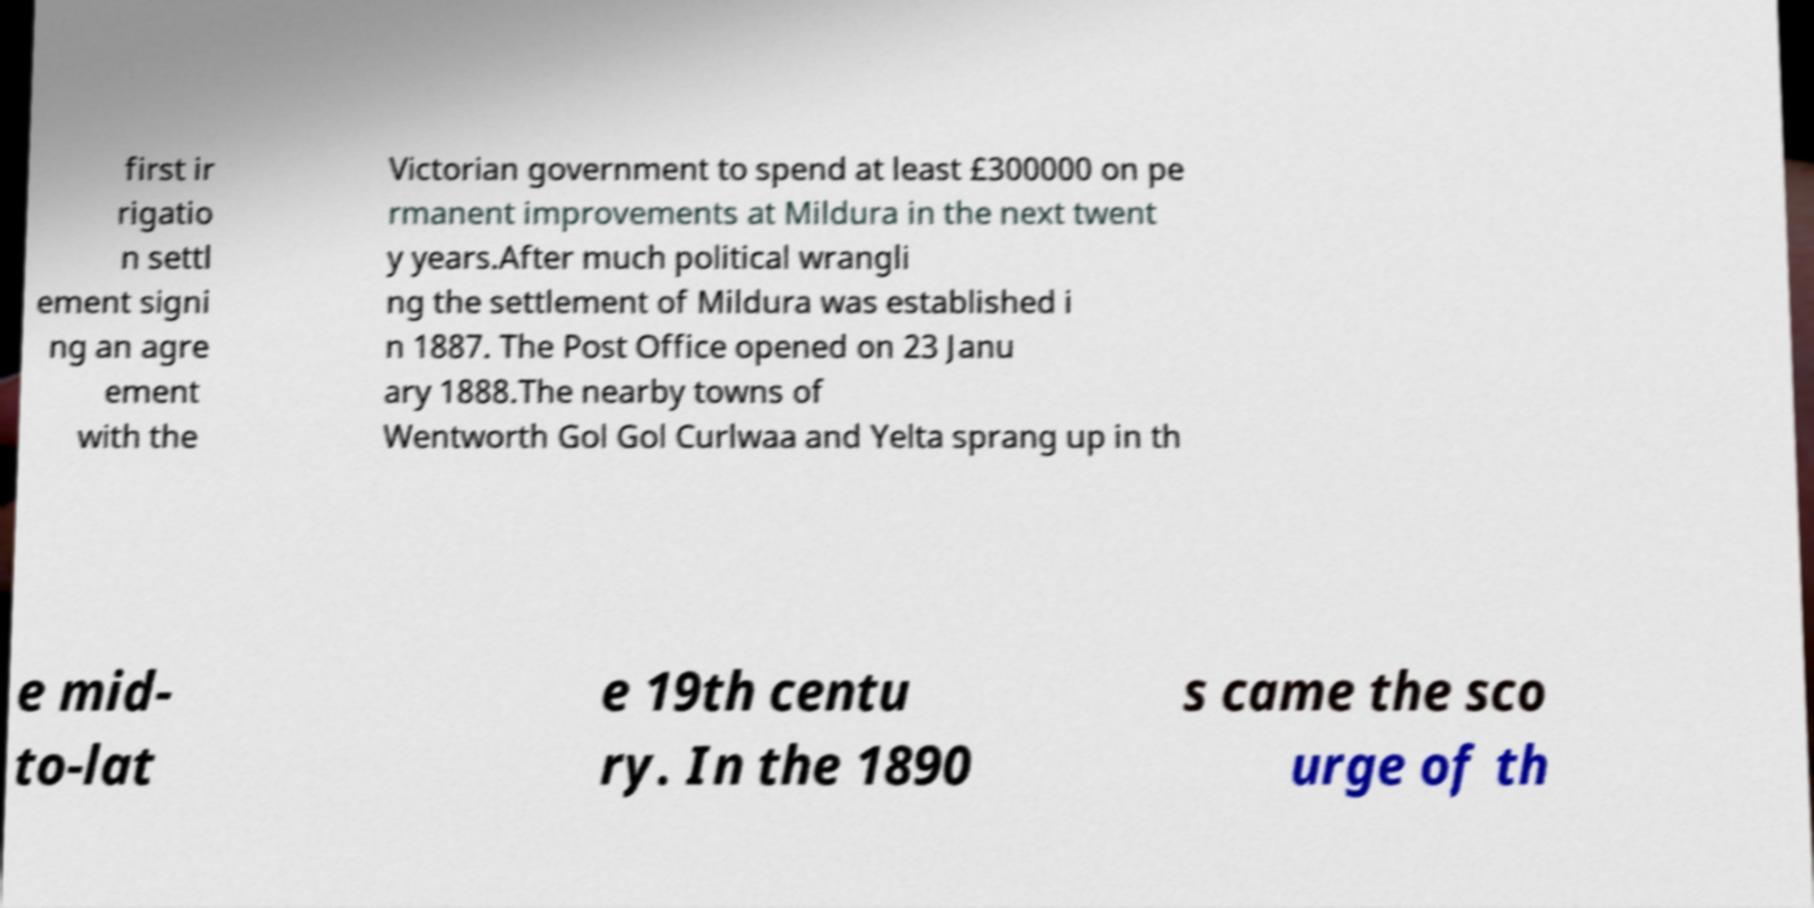Can you accurately transcribe the text from the provided image for me? first ir rigatio n settl ement signi ng an agre ement with the Victorian government to spend at least £300000 on pe rmanent improvements at Mildura in the next twent y years.After much political wrangli ng the settlement of Mildura was established i n 1887. The Post Office opened on 23 Janu ary 1888.The nearby towns of Wentworth Gol Gol Curlwaa and Yelta sprang up in th e mid- to-lat e 19th centu ry. In the 1890 s came the sco urge of th 